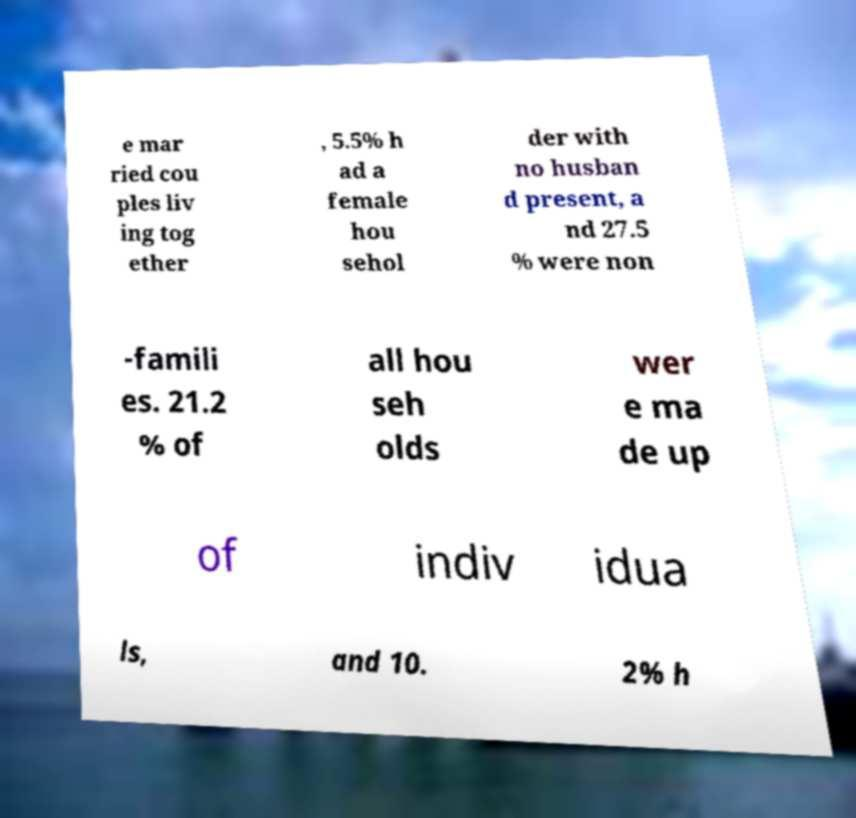Can you read and provide the text displayed in the image?This photo seems to have some interesting text. Can you extract and type it out for me? e mar ried cou ples liv ing tog ether , 5.5% h ad a female hou sehol der with no husban d present, a nd 27.5 % were non -famili es. 21.2 % of all hou seh olds wer e ma de up of indiv idua ls, and 10. 2% h 